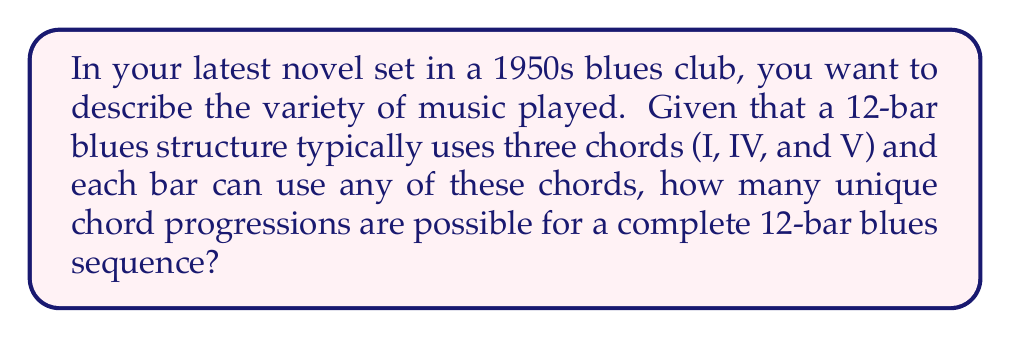Teach me how to tackle this problem. Let's approach this step-by-step:

1) In a 12-bar blues structure, we have 12 positions to fill with chords.

2) For each position, we have 3 choices of chords (I, IV, or V).

3) This is a classic example of the multiplication principle in combinatorics. When we have a series of independent choices, we multiply the number of options for each choice.

4) In this case, we have 3 choices for each of the 12 bars.

5) Mathematically, this can be expressed as:

   $$ \text{Total combinations} = 3^{12} $$

6) Let's calculate this:

   $$ 3^{12} = 3 \times 3 \times 3 \times 3 \times 3 \times 3 \times 3 \times 3 \times 3 \times 3 \times 3 \times 3 = 531,441 $$

Therefore, there are 531,441 possible unique chord progressions in a 12-bar blues structure using the three primary chords.
Answer: 531,441 